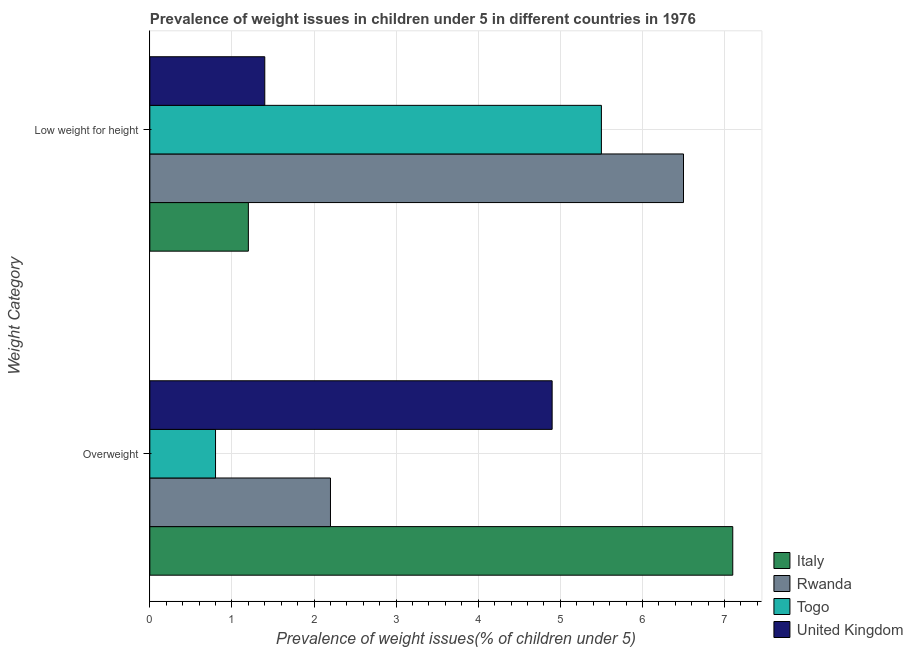How many groups of bars are there?
Offer a terse response. 2. Are the number of bars per tick equal to the number of legend labels?
Provide a succinct answer. Yes. What is the label of the 1st group of bars from the top?
Ensure brevity in your answer.  Low weight for height. What is the percentage of overweight children in United Kingdom?
Keep it short and to the point. 4.9. Across all countries, what is the minimum percentage of overweight children?
Your answer should be very brief. 0.8. In which country was the percentage of underweight children maximum?
Keep it short and to the point. Rwanda. In which country was the percentage of overweight children minimum?
Offer a very short reply. Togo. What is the total percentage of overweight children in the graph?
Your answer should be very brief. 15. What is the difference between the percentage of overweight children in Rwanda and that in Togo?
Your response must be concise. 1.4. What is the difference between the percentage of underweight children in United Kingdom and the percentage of overweight children in Rwanda?
Offer a terse response. -0.8. What is the average percentage of underweight children per country?
Your response must be concise. 3.65. What is the difference between the percentage of underweight children and percentage of overweight children in Rwanda?
Offer a very short reply. 4.3. In how many countries, is the percentage of underweight children greater than 2 %?
Offer a terse response. 2. What is the ratio of the percentage of overweight children in United Kingdom to that in Italy?
Offer a very short reply. 0.69. What does the 3rd bar from the top in Low weight for height represents?
Offer a terse response. Rwanda. How many countries are there in the graph?
Provide a succinct answer. 4. Are the values on the major ticks of X-axis written in scientific E-notation?
Your answer should be very brief. No. Does the graph contain any zero values?
Your answer should be compact. No. Does the graph contain grids?
Provide a succinct answer. Yes. How many legend labels are there?
Make the answer very short. 4. What is the title of the graph?
Ensure brevity in your answer.  Prevalence of weight issues in children under 5 in different countries in 1976. Does "Lithuania" appear as one of the legend labels in the graph?
Provide a succinct answer. No. What is the label or title of the X-axis?
Ensure brevity in your answer.  Prevalence of weight issues(% of children under 5). What is the label or title of the Y-axis?
Ensure brevity in your answer.  Weight Category. What is the Prevalence of weight issues(% of children under 5) in Italy in Overweight?
Keep it short and to the point. 7.1. What is the Prevalence of weight issues(% of children under 5) of Rwanda in Overweight?
Offer a terse response. 2.2. What is the Prevalence of weight issues(% of children under 5) of Togo in Overweight?
Your answer should be very brief. 0.8. What is the Prevalence of weight issues(% of children under 5) of United Kingdom in Overweight?
Offer a very short reply. 4.9. What is the Prevalence of weight issues(% of children under 5) of Italy in Low weight for height?
Ensure brevity in your answer.  1.2. What is the Prevalence of weight issues(% of children under 5) of Togo in Low weight for height?
Keep it short and to the point. 5.5. What is the Prevalence of weight issues(% of children under 5) in United Kingdom in Low weight for height?
Provide a succinct answer. 1.4. Across all Weight Category, what is the maximum Prevalence of weight issues(% of children under 5) of Italy?
Keep it short and to the point. 7.1. Across all Weight Category, what is the maximum Prevalence of weight issues(% of children under 5) of Rwanda?
Offer a very short reply. 6.5. Across all Weight Category, what is the maximum Prevalence of weight issues(% of children under 5) of United Kingdom?
Provide a short and direct response. 4.9. Across all Weight Category, what is the minimum Prevalence of weight issues(% of children under 5) in Italy?
Offer a terse response. 1.2. Across all Weight Category, what is the minimum Prevalence of weight issues(% of children under 5) of Rwanda?
Your answer should be compact. 2.2. Across all Weight Category, what is the minimum Prevalence of weight issues(% of children under 5) in Togo?
Keep it short and to the point. 0.8. Across all Weight Category, what is the minimum Prevalence of weight issues(% of children under 5) of United Kingdom?
Make the answer very short. 1.4. What is the total Prevalence of weight issues(% of children under 5) of Italy in the graph?
Your response must be concise. 8.3. What is the total Prevalence of weight issues(% of children under 5) of Togo in the graph?
Your response must be concise. 6.3. What is the difference between the Prevalence of weight issues(% of children under 5) of Rwanda in Overweight and that in Low weight for height?
Give a very brief answer. -4.3. What is the difference between the Prevalence of weight issues(% of children under 5) in Togo in Overweight and that in Low weight for height?
Your answer should be very brief. -4.7. What is the difference between the Prevalence of weight issues(% of children under 5) of United Kingdom in Overweight and that in Low weight for height?
Make the answer very short. 3.5. What is the difference between the Prevalence of weight issues(% of children under 5) in Italy in Overweight and the Prevalence of weight issues(% of children under 5) in United Kingdom in Low weight for height?
Provide a short and direct response. 5.7. What is the difference between the Prevalence of weight issues(% of children under 5) in Rwanda in Overweight and the Prevalence of weight issues(% of children under 5) in Togo in Low weight for height?
Make the answer very short. -3.3. What is the difference between the Prevalence of weight issues(% of children under 5) in Togo in Overweight and the Prevalence of weight issues(% of children under 5) in United Kingdom in Low weight for height?
Offer a terse response. -0.6. What is the average Prevalence of weight issues(% of children under 5) of Italy per Weight Category?
Your answer should be very brief. 4.15. What is the average Prevalence of weight issues(% of children under 5) in Rwanda per Weight Category?
Offer a terse response. 4.35. What is the average Prevalence of weight issues(% of children under 5) of Togo per Weight Category?
Ensure brevity in your answer.  3.15. What is the average Prevalence of weight issues(% of children under 5) in United Kingdom per Weight Category?
Offer a very short reply. 3.15. What is the difference between the Prevalence of weight issues(% of children under 5) of Italy and Prevalence of weight issues(% of children under 5) of Togo in Overweight?
Your answer should be very brief. 6.3. What is the difference between the Prevalence of weight issues(% of children under 5) in Italy and Prevalence of weight issues(% of children under 5) in Rwanda in Low weight for height?
Offer a terse response. -5.3. What is the difference between the Prevalence of weight issues(% of children under 5) in Italy and Prevalence of weight issues(% of children under 5) in United Kingdom in Low weight for height?
Your answer should be very brief. -0.2. What is the difference between the Prevalence of weight issues(% of children under 5) in Rwanda and Prevalence of weight issues(% of children under 5) in United Kingdom in Low weight for height?
Your answer should be compact. 5.1. What is the ratio of the Prevalence of weight issues(% of children under 5) in Italy in Overweight to that in Low weight for height?
Provide a short and direct response. 5.92. What is the ratio of the Prevalence of weight issues(% of children under 5) in Rwanda in Overweight to that in Low weight for height?
Your answer should be very brief. 0.34. What is the ratio of the Prevalence of weight issues(% of children under 5) in Togo in Overweight to that in Low weight for height?
Your answer should be very brief. 0.15. What is the ratio of the Prevalence of weight issues(% of children under 5) of United Kingdom in Overweight to that in Low weight for height?
Your answer should be very brief. 3.5. What is the difference between the highest and the second highest Prevalence of weight issues(% of children under 5) of Italy?
Offer a terse response. 5.9. What is the difference between the highest and the second highest Prevalence of weight issues(% of children under 5) in Rwanda?
Your answer should be compact. 4.3. What is the difference between the highest and the second highest Prevalence of weight issues(% of children under 5) of Togo?
Your answer should be very brief. 4.7. What is the difference between the highest and the second highest Prevalence of weight issues(% of children under 5) in United Kingdom?
Offer a terse response. 3.5. What is the difference between the highest and the lowest Prevalence of weight issues(% of children under 5) in Italy?
Keep it short and to the point. 5.9. What is the difference between the highest and the lowest Prevalence of weight issues(% of children under 5) in Rwanda?
Give a very brief answer. 4.3. 